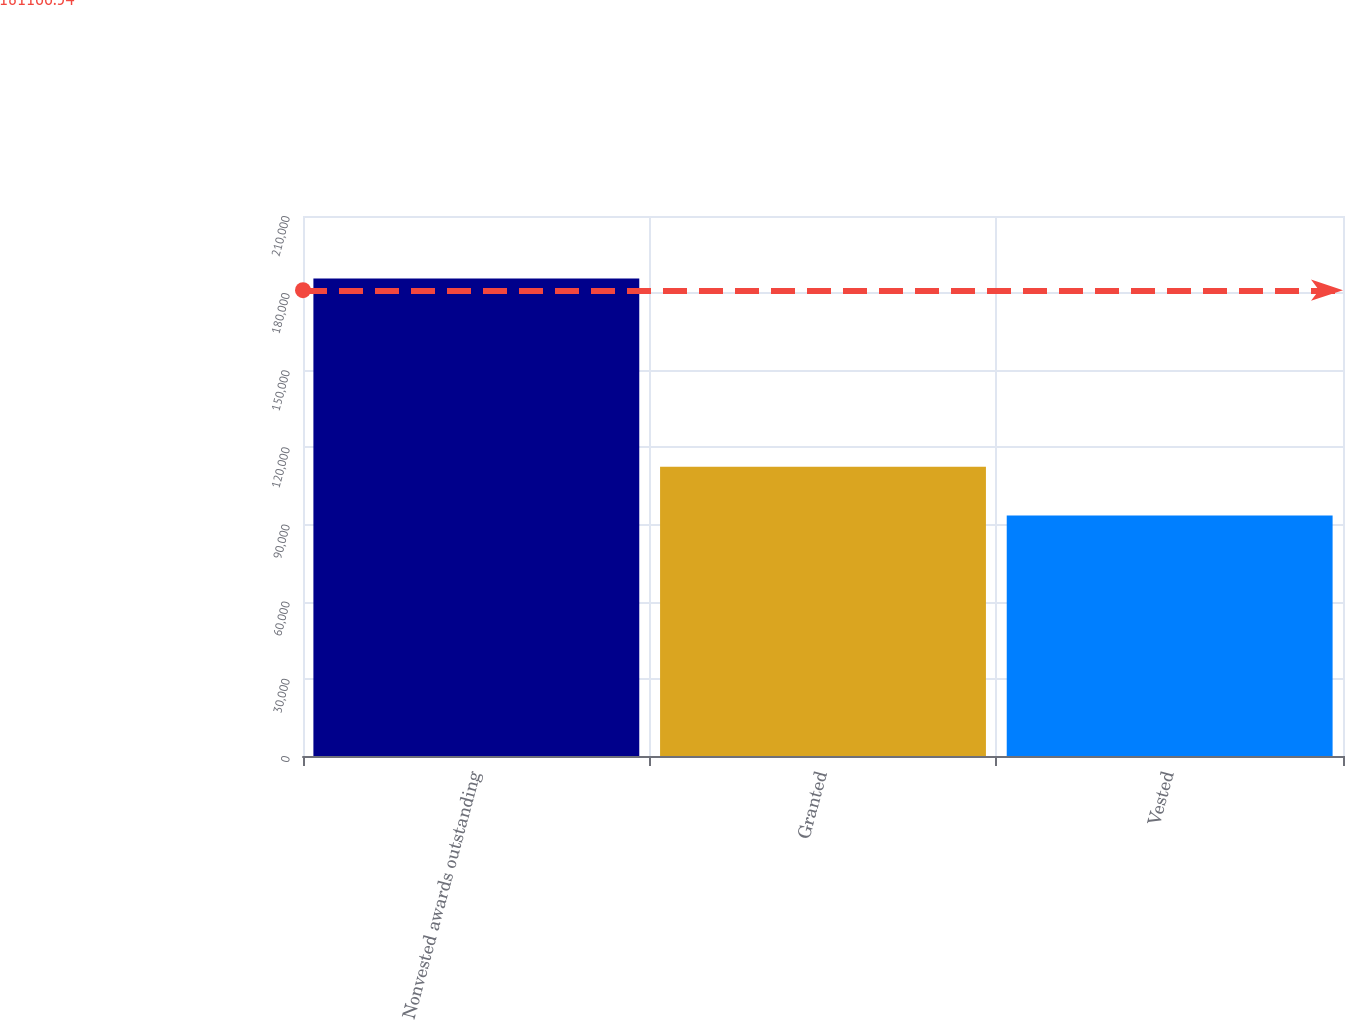Convert chart. <chart><loc_0><loc_0><loc_500><loc_500><bar_chart><fcel>Nonvested awards outstanding<fcel>Granted<fcel>Vested<nl><fcel>185700<fcel>112500<fcel>93500<nl></chart> 